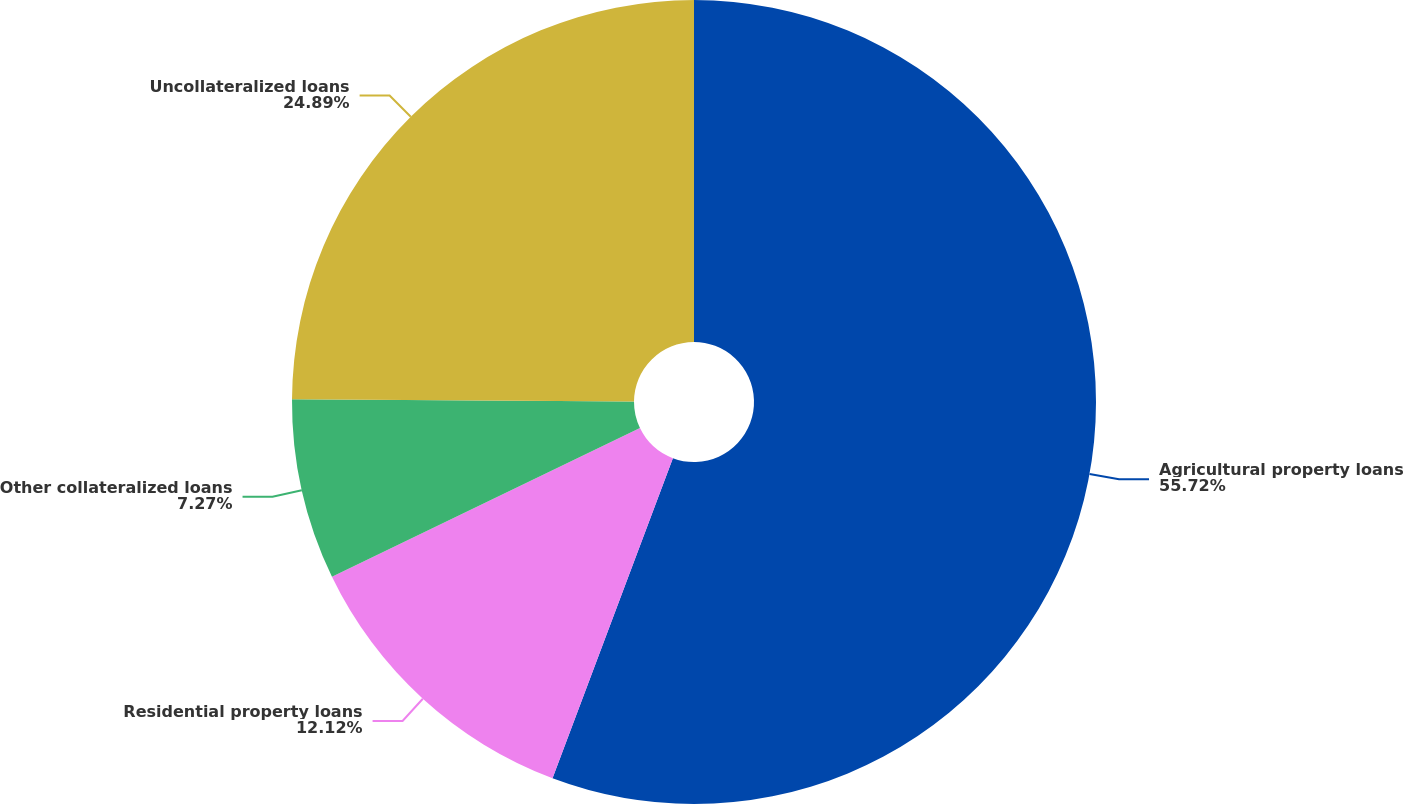<chart> <loc_0><loc_0><loc_500><loc_500><pie_chart><fcel>Agricultural property loans<fcel>Residential property loans<fcel>Other collateralized loans<fcel>Uncollateralized loans<nl><fcel>55.73%<fcel>12.12%<fcel>7.27%<fcel>24.89%<nl></chart> 